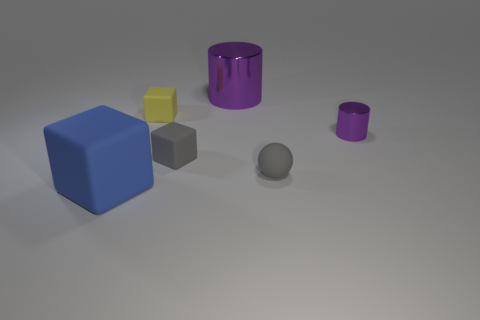There is a thing that is the same color as the small cylinder; what material is it?
Offer a very short reply. Metal. Does the large thing to the right of the blue thing have the same shape as the small yellow object?
Offer a terse response. No. How many objects are tiny cyan things or yellow rubber blocks?
Your answer should be compact. 1. Is the large thing that is right of the large blue rubber object made of the same material as the small cylinder?
Your response must be concise. Yes. What size is the ball?
Your answer should be very brief. Small. What shape is the object that is the same color as the tiny cylinder?
Make the answer very short. Cylinder. How many cylinders are big blue rubber objects or big purple metal things?
Offer a very short reply. 1. Is the number of tiny blocks that are in front of the tiny yellow thing the same as the number of yellow rubber cubes that are left of the small purple thing?
Make the answer very short. Yes. There is another shiny thing that is the same shape as the big purple thing; what size is it?
Provide a succinct answer. Small. There is a thing that is in front of the gray rubber block and on the left side of the big purple cylinder; what is its size?
Give a very brief answer. Large. 